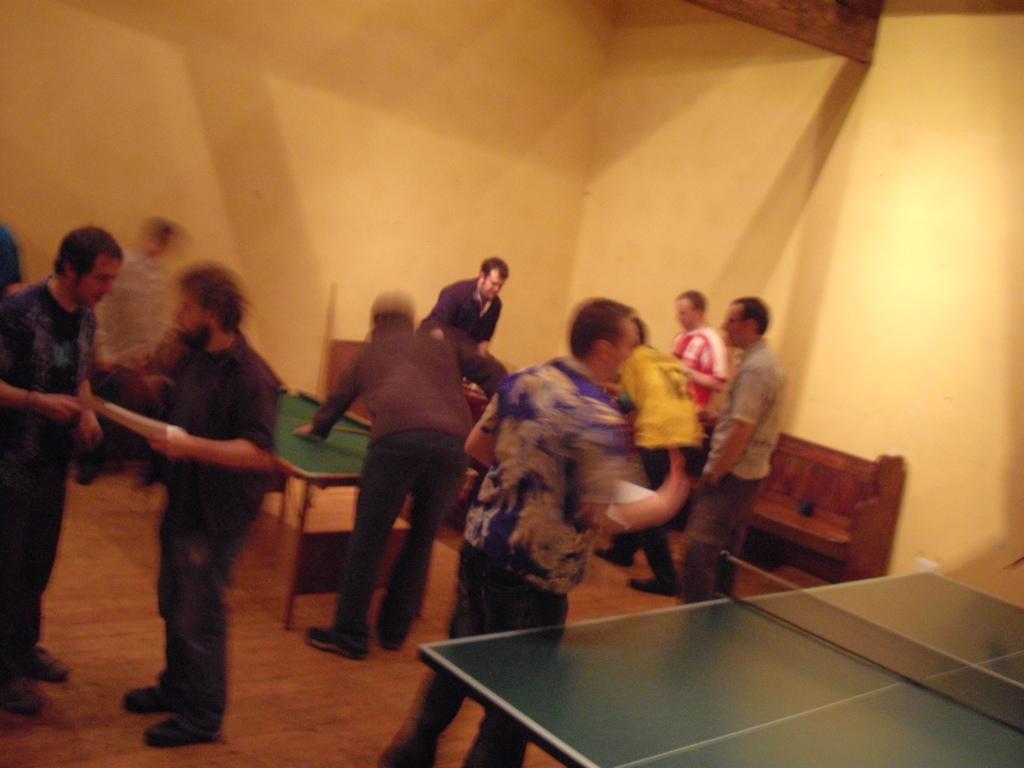Can you describe this image briefly? In this image we can see one man playing billiards game, on the right side of the image we can see a table tennis stand, in the background there are group of people standing, on the left side of marriage two men are standing and talking with each other. 